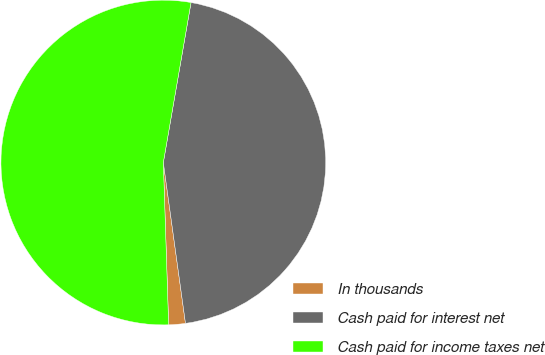<chart> <loc_0><loc_0><loc_500><loc_500><pie_chart><fcel>In thousands<fcel>Cash paid for interest net<fcel>Cash paid for income taxes net<nl><fcel>1.66%<fcel>45.09%<fcel>53.25%<nl></chart> 